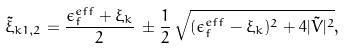Convert formula to latex. <formula><loc_0><loc_0><loc_500><loc_500>\tilde { \xi } _ { k 1 , 2 } = \frac { \epsilon ^ { e f f } _ { f } + \xi _ { k } } { 2 } \, \pm \frac { 1 } { 2 } \, \sqrt { ( \epsilon ^ { e f f } _ { f } - \xi _ { k } ) ^ { 2 } + 4 | \tilde { V } | ^ { 2 } } ,</formula> 